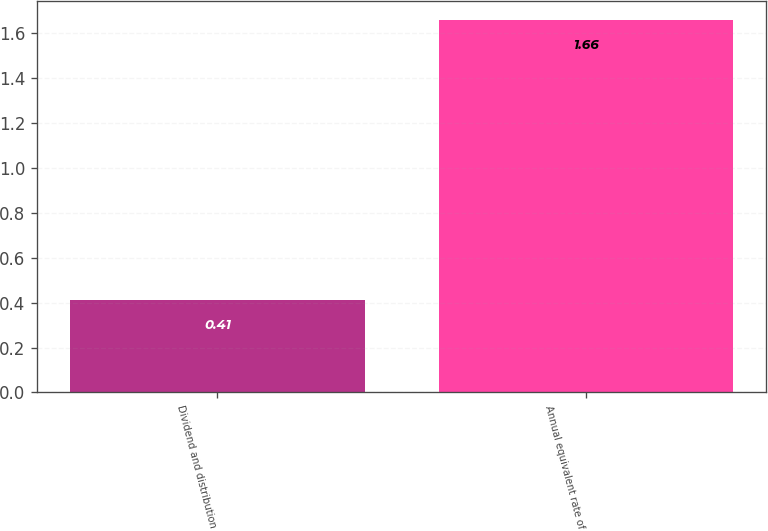Convert chart. <chart><loc_0><loc_0><loc_500><loc_500><bar_chart><fcel>Dividend and distribution<fcel>Annual equivalent rate of<nl><fcel>0.41<fcel>1.66<nl></chart> 